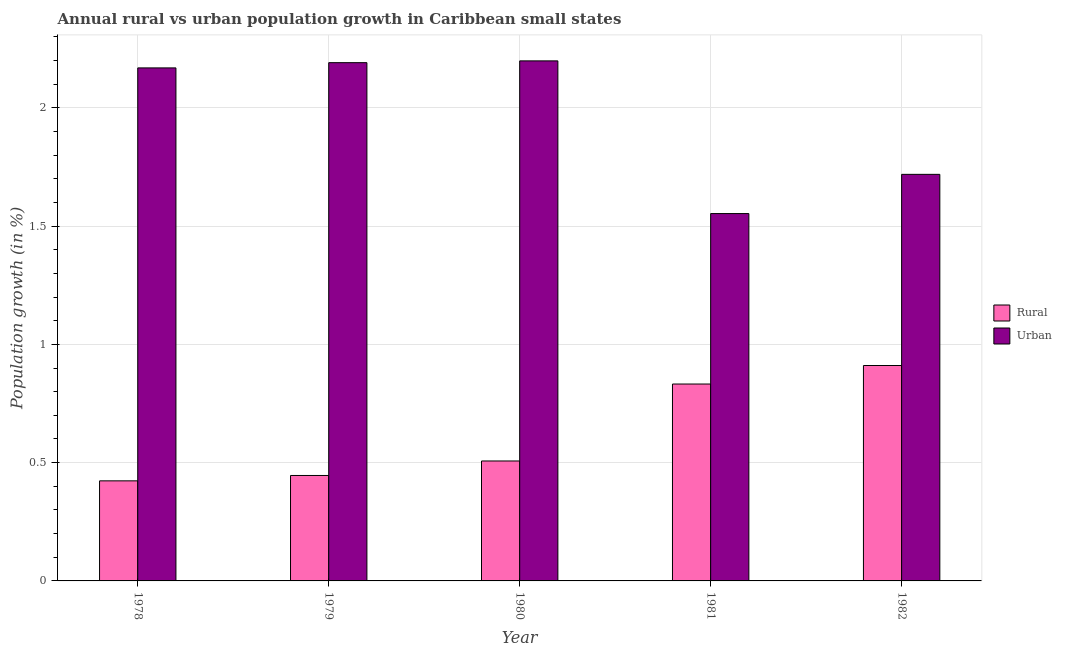Are the number of bars per tick equal to the number of legend labels?
Your answer should be very brief. Yes. Are the number of bars on each tick of the X-axis equal?
Keep it short and to the point. Yes. How many bars are there on the 1st tick from the left?
Ensure brevity in your answer.  2. In how many cases, is the number of bars for a given year not equal to the number of legend labels?
Your response must be concise. 0. What is the rural population growth in 1980?
Your response must be concise. 0.51. Across all years, what is the maximum urban population growth?
Provide a short and direct response. 2.2. Across all years, what is the minimum rural population growth?
Offer a terse response. 0.42. In which year was the rural population growth minimum?
Give a very brief answer. 1978. What is the total rural population growth in the graph?
Offer a very short reply. 3.12. What is the difference between the urban population growth in 1978 and that in 1982?
Offer a very short reply. 0.45. What is the difference between the rural population growth in 1980 and the urban population growth in 1982?
Give a very brief answer. -0.4. What is the average urban population growth per year?
Offer a very short reply. 1.97. In how many years, is the urban population growth greater than 0.9 %?
Your answer should be compact. 5. What is the ratio of the rural population growth in 1981 to that in 1982?
Give a very brief answer. 0.91. Is the urban population growth in 1980 less than that in 1982?
Your answer should be compact. No. Is the difference between the rural population growth in 1978 and 1982 greater than the difference between the urban population growth in 1978 and 1982?
Your answer should be very brief. No. What is the difference between the highest and the second highest rural population growth?
Offer a very short reply. 0.08. What is the difference between the highest and the lowest urban population growth?
Give a very brief answer. 0.65. What does the 1st bar from the left in 1981 represents?
Offer a terse response. Rural. What does the 2nd bar from the right in 1980 represents?
Provide a short and direct response. Rural. How many bars are there?
Keep it short and to the point. 10. How many years are there in the graph?
Keep it short and to the point. 5. What is the difference between two consecutive major ticks on the Y-axis?
Keep it short and to the point. 0.5. Are the values on the major ticks of Y-axis written in scientific E-notation?
Keep it short and to the point. No. Does the graph contain grids?
Ensure brevity in your answer.  Yes. What is the title of the graph?
Offer a very short reply. Annual rural vs urban population growth in Caribbean small states. What is the label or title of the Y-axis?
Your answer should be compact. Population growth (in %). What is the Population growth (in %) in Rural in 1978?
Give a very brief answer. 0.42. What is the Population growth (in %) in Urban  in 1978?
Ensure brevity in your answer.  2.17. What is the Population growth (in %) of Rural in 1979?
Your answer should be very brief. 0.45. What is the Population growth (in %) of Urban  in 1979?
Provide a succinct answer. 2.19. What is the Population growth (in %) of Rural in 1980?
Offer a very short reply. 0.51. What is the Population growth (in %) in Urban  in 1980?
Offer a terse response. 2.2. What is the Population growth (in %) in Rural in 1981?
Offer a very short reply. 0.83. What is the Population growth (in %) in Urban  in 1981?
Provide a succinct answer. 1.55. What is the Population growth (in %) of Rural in 1982?
Your answer should be very brief. 0.91. What is the Population growth (in %) of Urban  in 1982?
Offer a terse response. 1.72. Across all years, what is the maximum Population growth (in %) of Rural?
Ensure brevity in your answer.  0.91. Across all years, what is the maximum Population growth (in %) of Urban ?
Your answer should be compact. 2.2. Across all years, what is the minimum Population growth (in %) of Rural?
Keep it short and to the point. 0.42. Across all years, what is the minimum Population growth (in %) of Urban ?
Provide a succinct answer. 1.55. What is the total Population growth (in %) in Rural in the graph?
Offer a very short reply. 3.12. What is the total Population growth (in %) in Urban  in the graph?
Ensure brevity in your answer.  9.83. What is the difference between the Population growth (in %) of Rural in 1978 and that in 1979?
Give a very brief answer. -0.02. What is the difference between the Population growth (in %) in Urban  in 1978 and that in 1979?
Ensure brevity in your answer.  -0.02. What is the difference between the Population growth (in %) of Rural in 1978 and that in 1980?
Offer a very short reply. -0.08. What is the difference between the Population growth (in %) of Urban  in 1978 and that in 1980?
Your answer should be compact. -0.03. What is the difference between the Population growth (in %) of Rural in 1978 and that in 1981?
Give a very brief answer. -0.41. What is the difference between the Population growth (in %) of Urban  in 1978 and that in 1981?
Provide a succinct answer. 0.62. What is the difference between the Population growth (in %) in Rural in 1978 and that in 1982?
Your answer should be compact. -0.49. What is the difference between the Population growth (in %) of Urban  in 1978 and that in 1982?
Your answer should be compact. 0.45. What is the difference between the Population growth (in %) of Rural in 1979 and that in 1980?
Provide a short and direct response. -0.06. What is the difference between the Population growth (in %) of Urban  in 1979 and that in 1980?
Provide a short and direct response. -0.01. What is the difference between the Population growth (in %) of Rural in 1979 and that in 1981?
Your response must be concise. -0.39. What is the difference between the Population growth (in %) of Urban  in 1979 and that in 1981?
Your answer should be compact. 0.64. What is the difference between the Population growth (in %) of Rural in 1979 and that in 1982?
Ensure brevity in your answer.  -0.46. What is the difference between the Population growth (in %) in Urban  in 1979 and that in 1982?
Provide a succinct answer. 0.47. What is the difference between the Population growth (in %) of Rural in 1980 and that in 1981?
Offer a terse response. -0.33. What is the difference between the Population growth (in %) of Urban  in 1980 and that in 1981?
Give a very brief answer. 0.65. What is the difference between the Population growth (in %) in Rural in 1980 and that in 1982?
Give a very brief answer. -0.4. What is the difference between the Population growth (in %) of Urban  in 1980 and that in 1982?
Make the answer very short. 0.48. What is the difference between the Population growth (in %) in Rural in 1981 and that in 1982?
Give a very brief answer. -0.08. What is the difference between the Population growth (in %) in Urban  in 1981 and that in 1982?
Make the answer very short. -0.17. What is the difference between the Population growth (in %) in Rural in 1978 and the Population growth (in %) in Urban  in 1979?
Provide a short and direct response. -1.77. What is the difference between the Population growth (in %) in Rural in 1978 and the Population growth (in %) in Urban  in 1980?
Provide a succinct answer. -1.78. What is the difference between the Population growth (in %) of Rural in 1978 and the Population growth (in %) of Urban  in 1981?
Give a very brief answer. -1.13. What is the difference between the Population growth (in %) in Rural in 1978 and the Population growth (in %) in Urban  in 1982?
Your answer should be very brief. -1.3. What is the difference between the Population growth (in %) in Rural in 1979 and the Population growth (in %) in Urban  in 1980?
Provide a short and direct response. -1.75. What is the difference between the Population growth (in %) in Rural in 1979 and the Population growth (in %) in Urban  in 1981?
Offer a very short reply. -1.11. What is the difference between the Population growth (in %) in Rural in 1979 and the Population growth (in %) in Urban  in 1982?
Offer a terse response. -1.27. What is the difference between the Population growth (in %) of Rural in 1980 and the Population growth (in %) of Urban  in 1981?
Your answer should be compact. -1.05. What is the difference between the Population growth (in %) of Rural in 1980 and the Population growth (in %) of Urban  in 1982?
Provide a short and direct response. -1.21. What is the difference between the Population growth (in %) of Rural in 1981 and the Population growth (in %) of Urban  in 1982?
Your answer should be very brief. -0.89. What is the average Population growth (in %) of Rural per year?
Give a very brief answer. 0.62. What is the average Population growth (in %) of Urban  per year?
Your answer should be very brief. 1.97. In the year 1978, what is the difference between the Population growth (in %) in Rural and Population growth (in %) in Urban ?
Give a very brief answer. -1.75. In the year 1979, what is the difference between the Population growth (in %) in Rural and Population growth (in %) in Urban ?
Provide a short and direct response. -1.75. In the year 1980, what is the difference between the Population growth (in %) in Rural and Population growth (in %) in Urban ?
Ensure brevity in your answer.  -1.69. In the year 1981, what is the difference between the Population growth (in %) in Rural and Population growth (in %) in Urban ?
Your answer should be compact. -0.72. In the year 1982, what is the difference between the Population growth (in %) of Rural and Population growth (in %) of Urban ?
Provide a succinct answer. -0.81. What is the ratio of the Population growth (in %) of Rural in 1978 to that in 1979?
Ensure brevity in your answer.  0.95. What is the ratio of the Population growth (in %) of Rural in 1978 to that in 1980?
Provide a short and direct response. 0.83. What is the ratio of the Population growth (in %) of Urban  in 1978 to that in 1980?
Offer a terse response. 0.99. What is the ratio of the Population growth (in %) of Rural in 1978 to that in 1981?
Make the answer very short. 0.51. What is the ratio of the Population growth (in %) of Urban  in 1978 to that in 1981?
Offer a very short reply. 1.4. What is the ratio of the Population growth (in %) in Rural in 1978 to that in 1982?
Provide a succinct answer. 0.46. What is the ratio of the Population growth (in %) in Urban  in 1978 to that in 1982?
Your answer should be very brief. 1.26. What is the ratio of the Population growth (in %) of Rural in 1979 to that in 1980?
Ensure brevity in your answer.  0.88. What is the ratio of the Population growth (in %) in Urban  in 1979 to that in 1980?
Keep it short and to the point. 1. What is the ratio of the Population growth (in %) in Rural in 1979 to that in 1981?
Make the answer very short. 0.54. What is the ratio of the Population growth (in %) in Urban  in 1979 to that in 1981?
Your answer should be compact. 1.41. What is the ratio of the Population growth (in %) of Rural in 1979 to that in 1982?
Make the answer very short. 0.49. What is the ratio of the Population growth (in %) in Urban  in 1979 to that in 1982?
Keep it short and to the point. 1.27. What is the ratio of the Population growth (in %) in Rural in 1980 to that in 1981?
Make the answer very short. 0.61. What is the ratio of the Population growth (in %) in Urban  in 1980 to that in 1981?
Your response must be concise. 1.42. What is the ratio of the Population growth (in %) in Rural in 1980 to that in 1982?
Make the answer very short. 0.56. What is the ratio of the Population growth (in %) in Urban  in 1980 to that in 1982?
Provide a short and direct response. 1.28. What is the ratio of the Population growth (in %) in Rural in 1981 to that in 1982?
Ensure brevity in your answer.  0.91. What is the ratio of the Population growth (in %) of Urban  in 1981 to that in 1982?
Offer a very short reply. 0.9. What is the difference between the highest and the second highest Population growth (in %) in Rural?
Give a very brief answer. 0.08. What is the difference between the highest and the second highest Population growth (in %) of Urban ?
Offer a very short reply. 0.01. What is the difference between the highest and the lowest Population growth (in %) in Rural?
Keep it short and to the point. 0.49. What is the difference between the highest and the lowest Population growth (in %) of Urban ?
Provide a succinct answer. 0.65. 